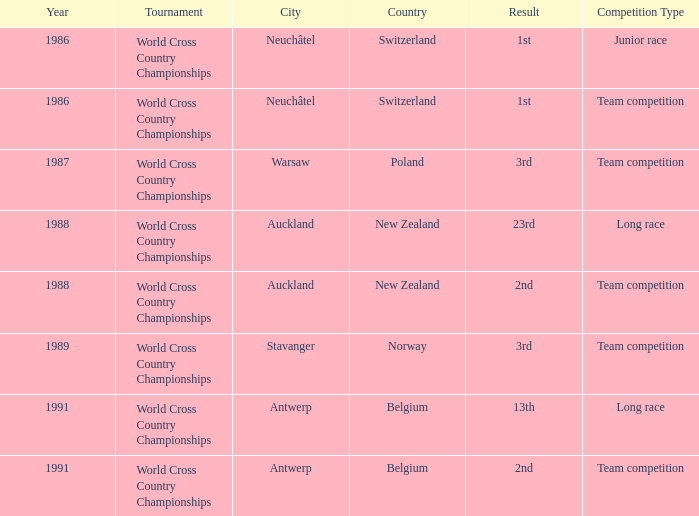Which venue had an extra of Team Competition and a result of 1st? Neuchâtel , Switzerland. 